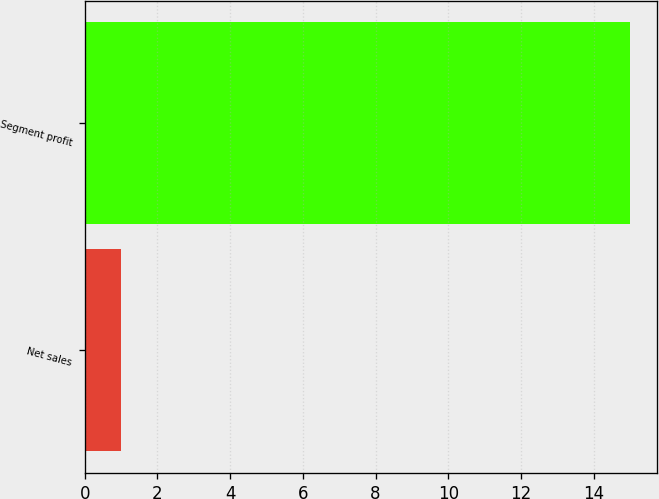Convert chart to OTSL. <chart><loc_0><loc_0><loc_500><loc_500><bar_chart><fcel>Net sales<fcel>Segment profit<nl><fcel>1<fcel>15<nl></chart> 